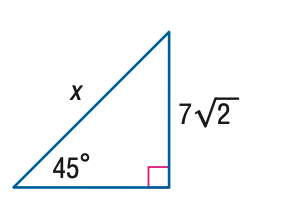Question: Find x.
Choices:
A. 7
B. 14
C. 14 \sqrt { 2 }
D. 28
Answer with the letter. Answer: B 